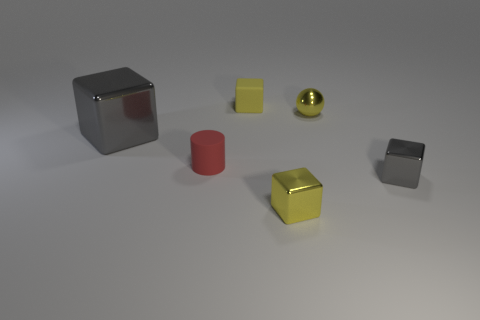Subtract all large cubes. How many cubes are left? 3 Subtract 2 cubes. How many cubes are left? 2 Add 3 small gray shiny things. How many objects exist? 9 Subtract all balls. How many objects are left? 5 Subtract all brown cubes. Subtract all green cylinders. How many cubes are left? 4 Subtract 1 red cylinders. How many objects are left? 5 Subtract all tiny green matte balls. Subtract all tiny matte things. How many objects are left? 4 Add 5 gray metallic blocks. How many gray metallic blocks are left? 7 Add 5 tiny cyan shiny balls. How many tiny cyan shiny balls exist? 5 